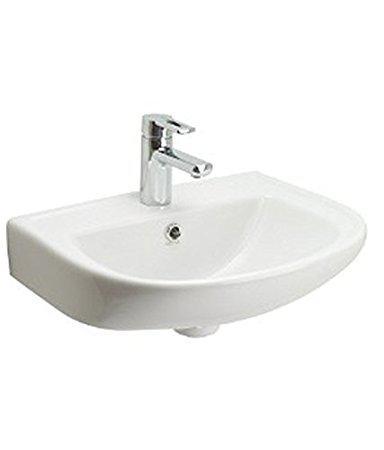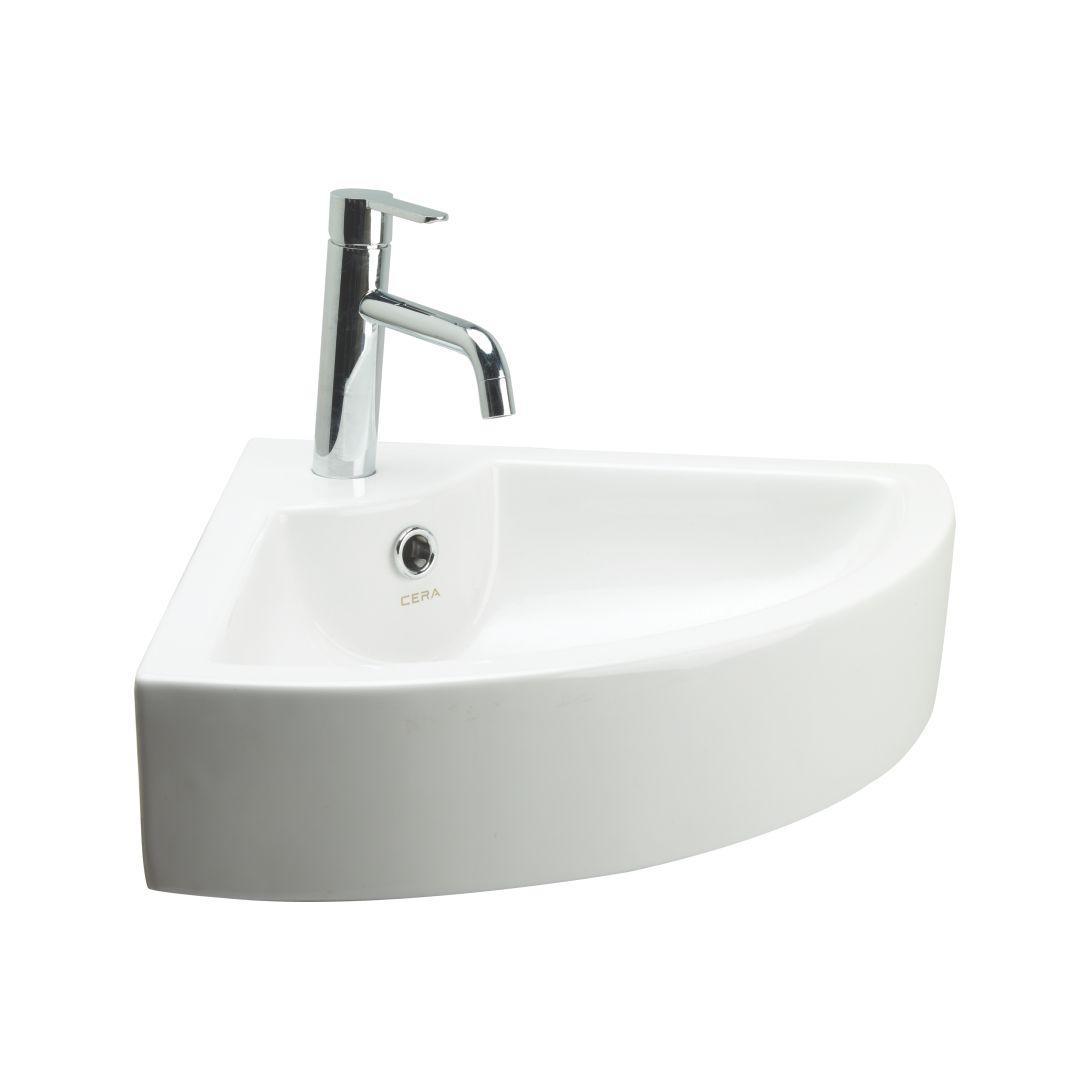The first image is the image on the left, the second image is the image on the right. Given the left and right images, does the statement "There is a square sink in one of the images." hold true? Answer yes or no. No. 